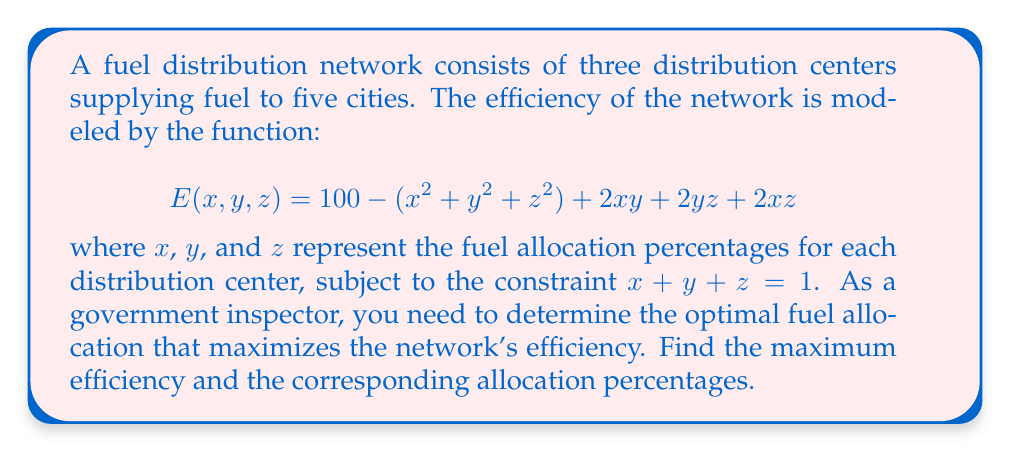Could you help me with this problem? To solve this optimization problem with the given constraint, we can use the method of Lagrange multipliers:

1. Form the Lagrangian function:
   $$L(x,y,z,\lambda) = 100 - (x^2 + y^2 + z^2) + 2xy + 2yz + 2xz + \lambda(x + y + z - 1)$$

2. Calculate partial derivatives and set them to zero:
   $$\frac{\partial L}{\partial x} = -2x + 2y + 2z + \lambda = 0$$
   $$\frac{\partial L}{\partial y} = -2y + 2x + 2z + \lambda = 0$$
   $$\frac{\partial L}{\partial z} = -2z + 2x + 2y + \lambda = 0$$
   $$\frac{\partial L}{\partial \lambda} = x + y + z - 1 = 0$$

3. From the first three equations, we can deduce that $x = y = z$. Substituting this into the fourth equation:
   $$3x = 1$$
   $$x = y = z = \frac{1}{3}$$

4. Calculate the maximum efficiency by substituting these values into the original function:
   $$E(\frac{1}{3},\frac{1}{3},\frac{1}{3}) = 100 - (\frac{1}{9} + \frac{1}{9} + \frac{1}{9}) + 2(\frac{1}{9} + \frac{1}{9} + \frac{1}{9})$$
   $$= 100 - \frac{3}{9} + \frac{6}{9} = 100 + \frac{3}{9} = 100\frac{1}{3}$$

Therefore, the maximum efficiency is $100\frac{1}{3}$ or $\frac{301}{3}$, achieved when the fuel is distributed equally among the three distribution centers.
Answer: Maximum efficiency: $\frac{301}{3}$; Optimal allocation: $x = y = z = \frac{1}{3}$ 